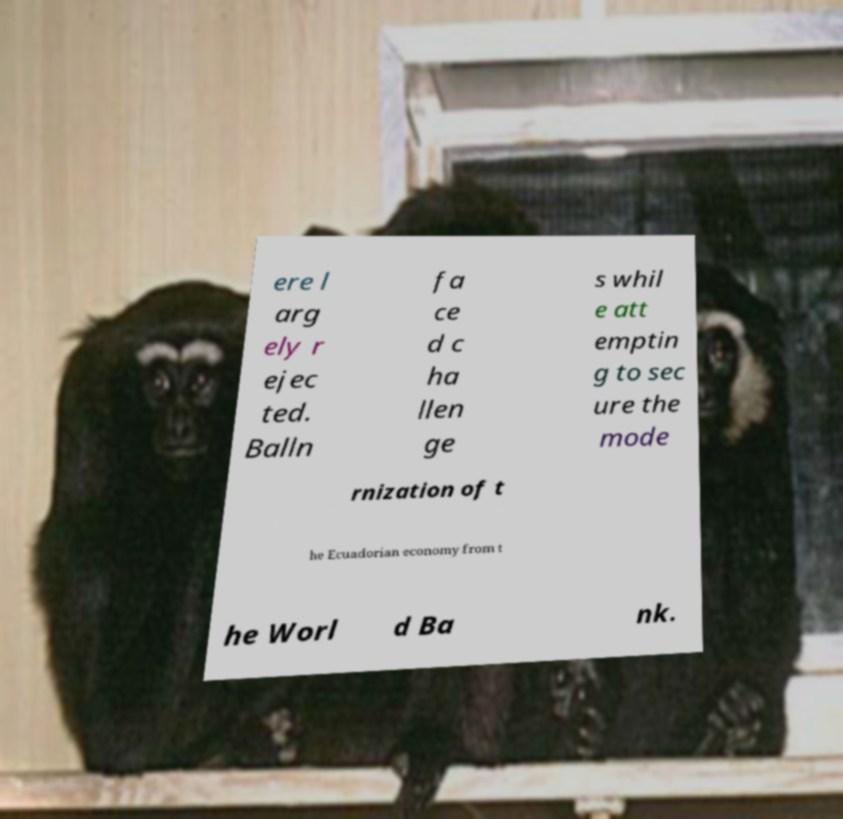What messages or text are displayed in this image? I need them in a readable, typed format. ere l arg ely r ejec ted. Balln fa ce d c ha llen ge s whil e att emptin g to sec ure the mode rnization of t he Ecuadorian economy from t he Worl d Ba nk. 